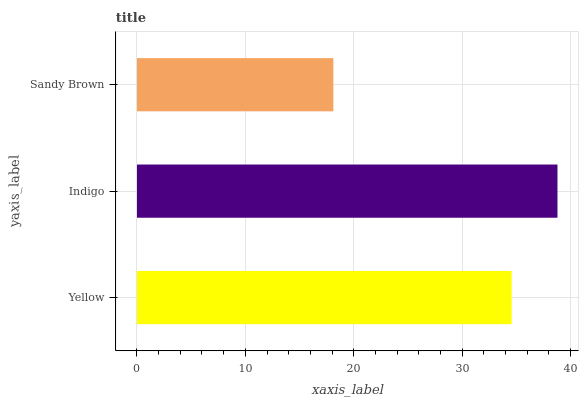Is Sandy Brown the minimum?
Answer yes or no. Yes. Is Indigo the maximum?
Answer yes or no. Yes. Is Indigo the minimum?
Answer yes or no. No. Is Sandy Brown the maximum?
Answer yes or no. No. Is Indigo greater than Sandy Brown?
Answer yes or no. Yes. Is Sandy Brown less than Indigo?
Answer yes or no. Yes. Is Sandy Brown greater than Indigo?
Answer yes or no. No. Is Indigo less than Sandy Brown?
Answer yes or no. No. Is Yellow the high median?
Answer yes or no. Yes. Is Yellow the low median?
Answer yes or no. Yes. Is Sandy Brown the high median?
Answer yes or no. No. Is Sandy Brown the low median?
Answer yes or no. No. 